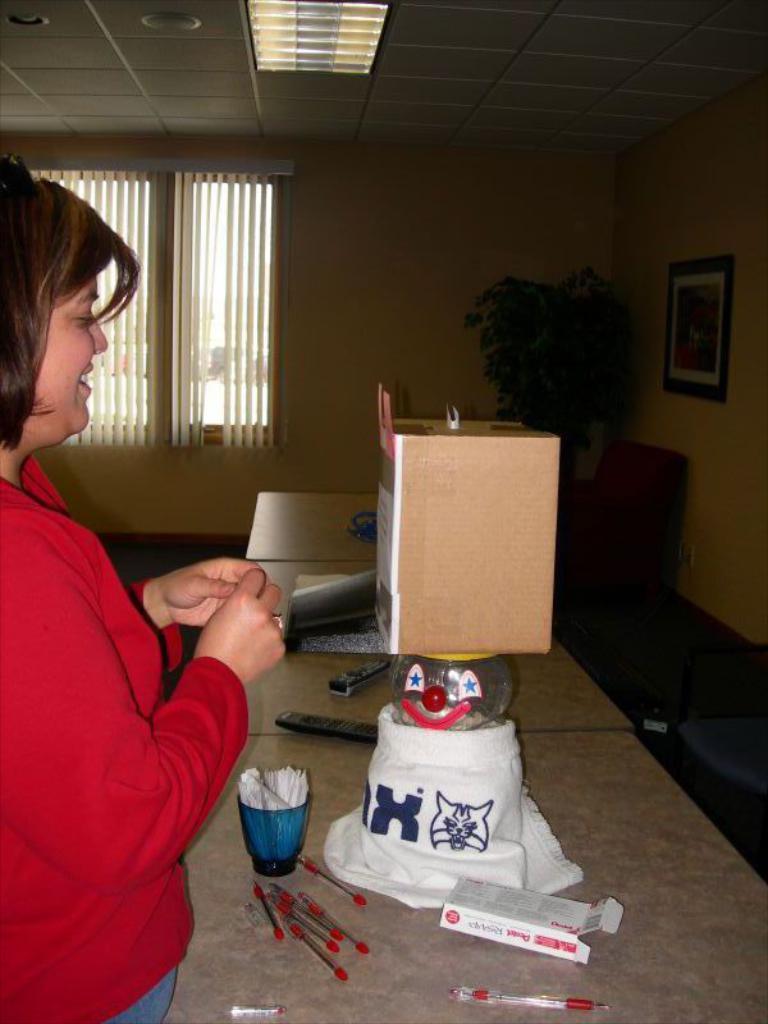In one or two sentences, can you explain what this image depicts? To the left side of the image there is a lady wearing a red color dress. In front of her there is a table on which there are pens, glass, remote and other objects. In the background of the image there is wall, window. There is a chair, plant. At the top of the image there is ceiling with lights. To the right side of the image there is a wall with photo frame. 